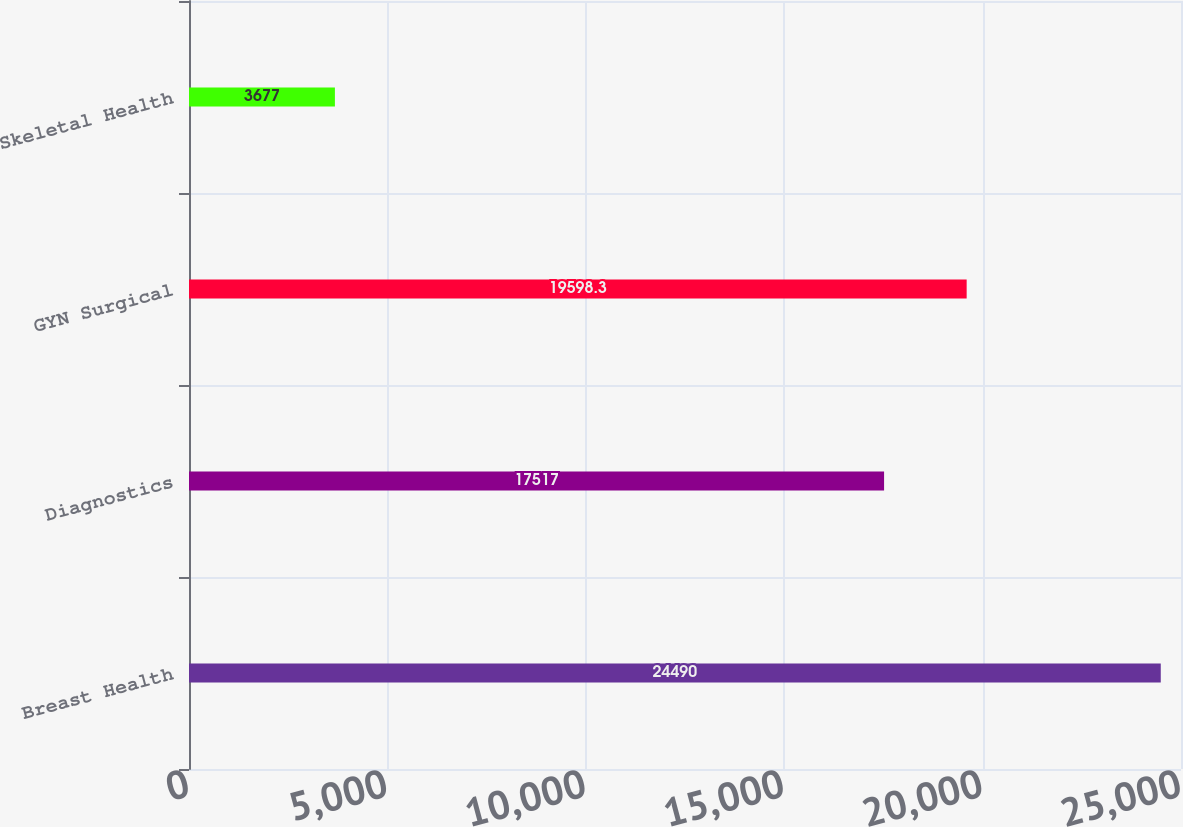Convert chart. <chart><loc_0><loc_0><loc_500><loc_500><bar_chart><fcel>Breast Health<fcel>Diagnostics<fcel>GYN Surgical<fcel>Skeletal Health<nl><fcel>24490<fcel>17517<fcel>19598.3<fcel>3677<nl></chart> 